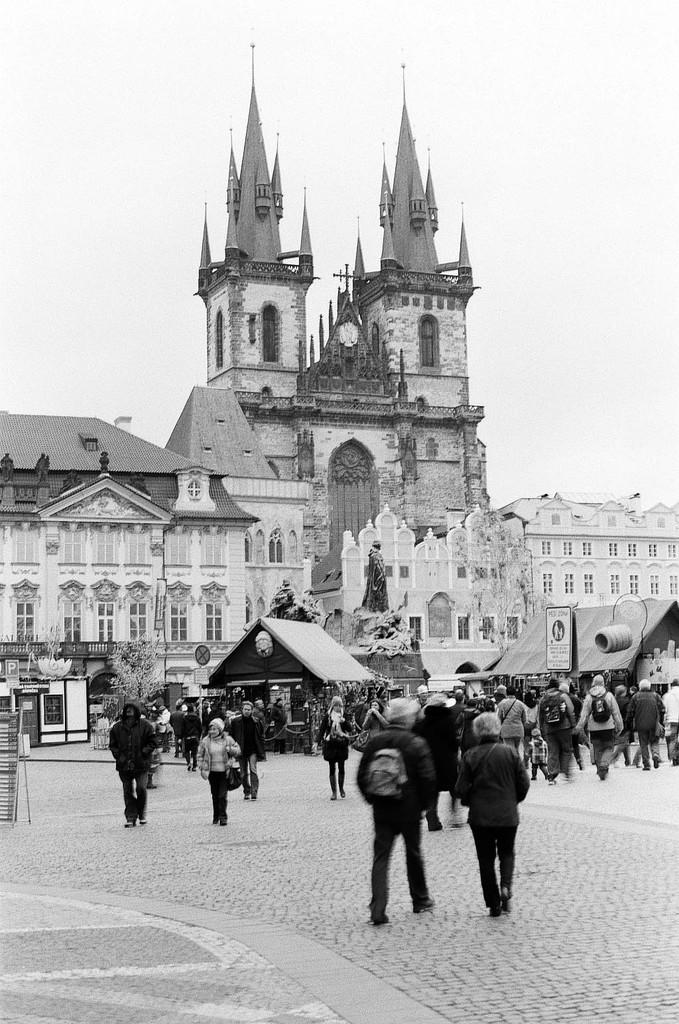What is the main subject in the foreground of the image? There is a crowd in the foreground of the image. Where is the crowd located? The crowd is on the road. What can be seen in the background of the image? There is a statue and buildings in the background of the image. What is visible at the top of the image? The sky is visible at the top of the image. When was the image taken? The image was taken during the day. What type of sink can be seen in the image? There is no sink present in the image. What is the chemical symbol for zinc that can be found in the image? There is no reference to zinc or any chemical symbols in the image. 